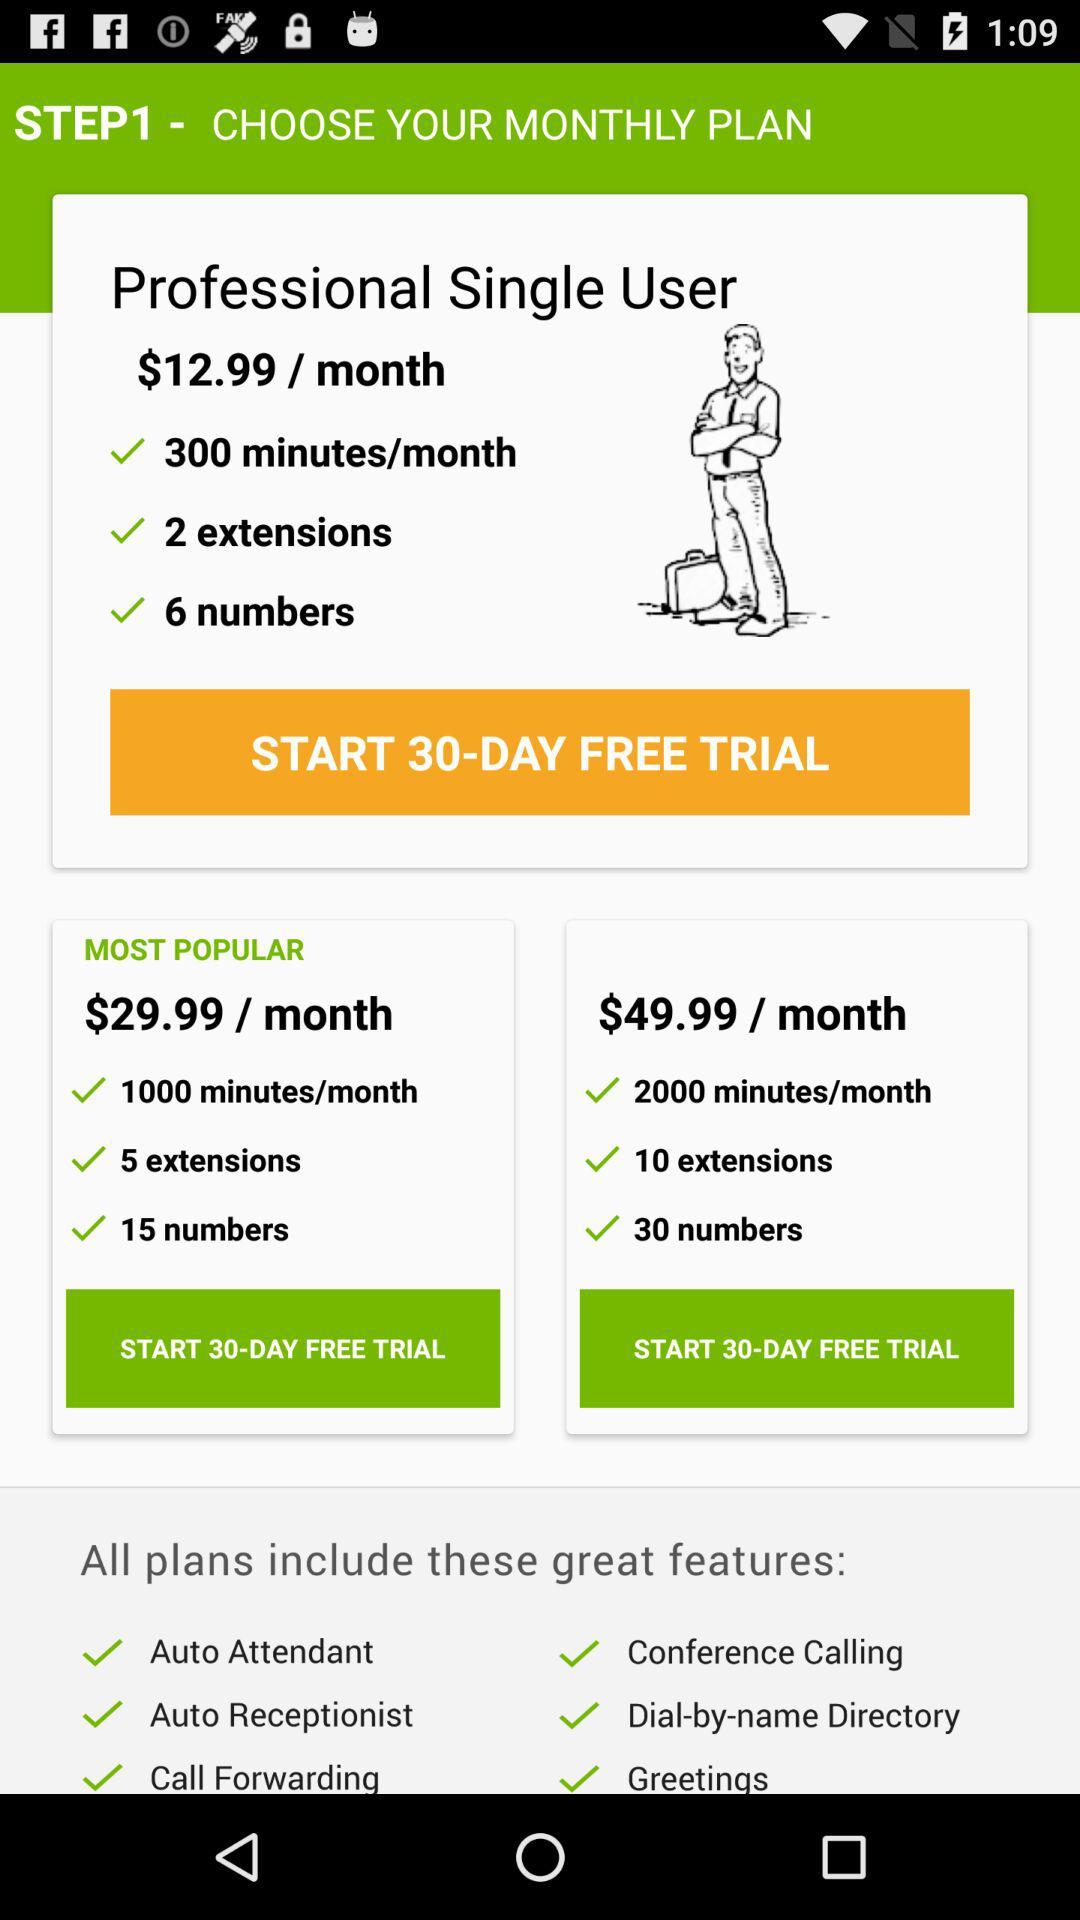What is the cost of the plan having 10 extensions? The cost is $49.99 per month. 